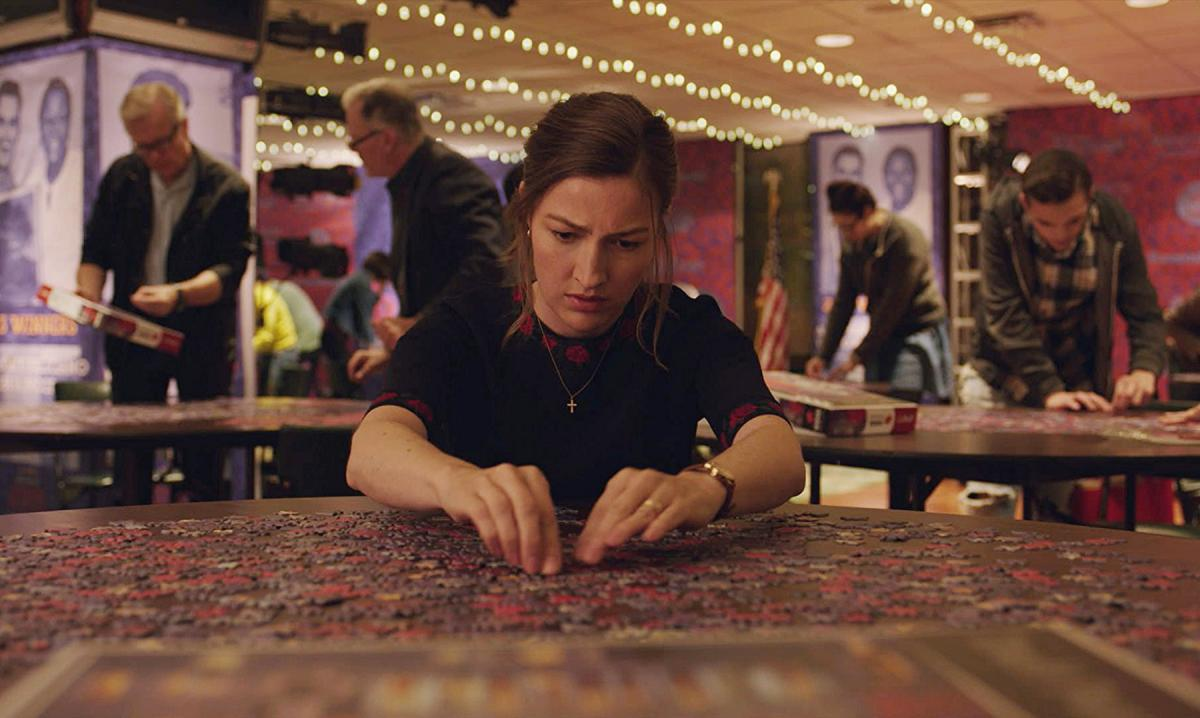Can you describe the mood of the scene portrayed in the image? The mood in the image is one of focused engagement and quiet intensity. The dim lighting and the soft glow of string lights add a warm, cozy atmosphere to the space, while individuals engrossed in their puzzles create a sense of community and shared interest. What do the posters in the background suggest about the setting? The posters in the background, showing various colorful designs and figures, suggest that the setting might be a public space or a social club dedicated to puzzle enthusiasts. This setting likely hosts regular events or gatherings centered around puzzle building, indicated by how well-organized and lively the scene appears. 